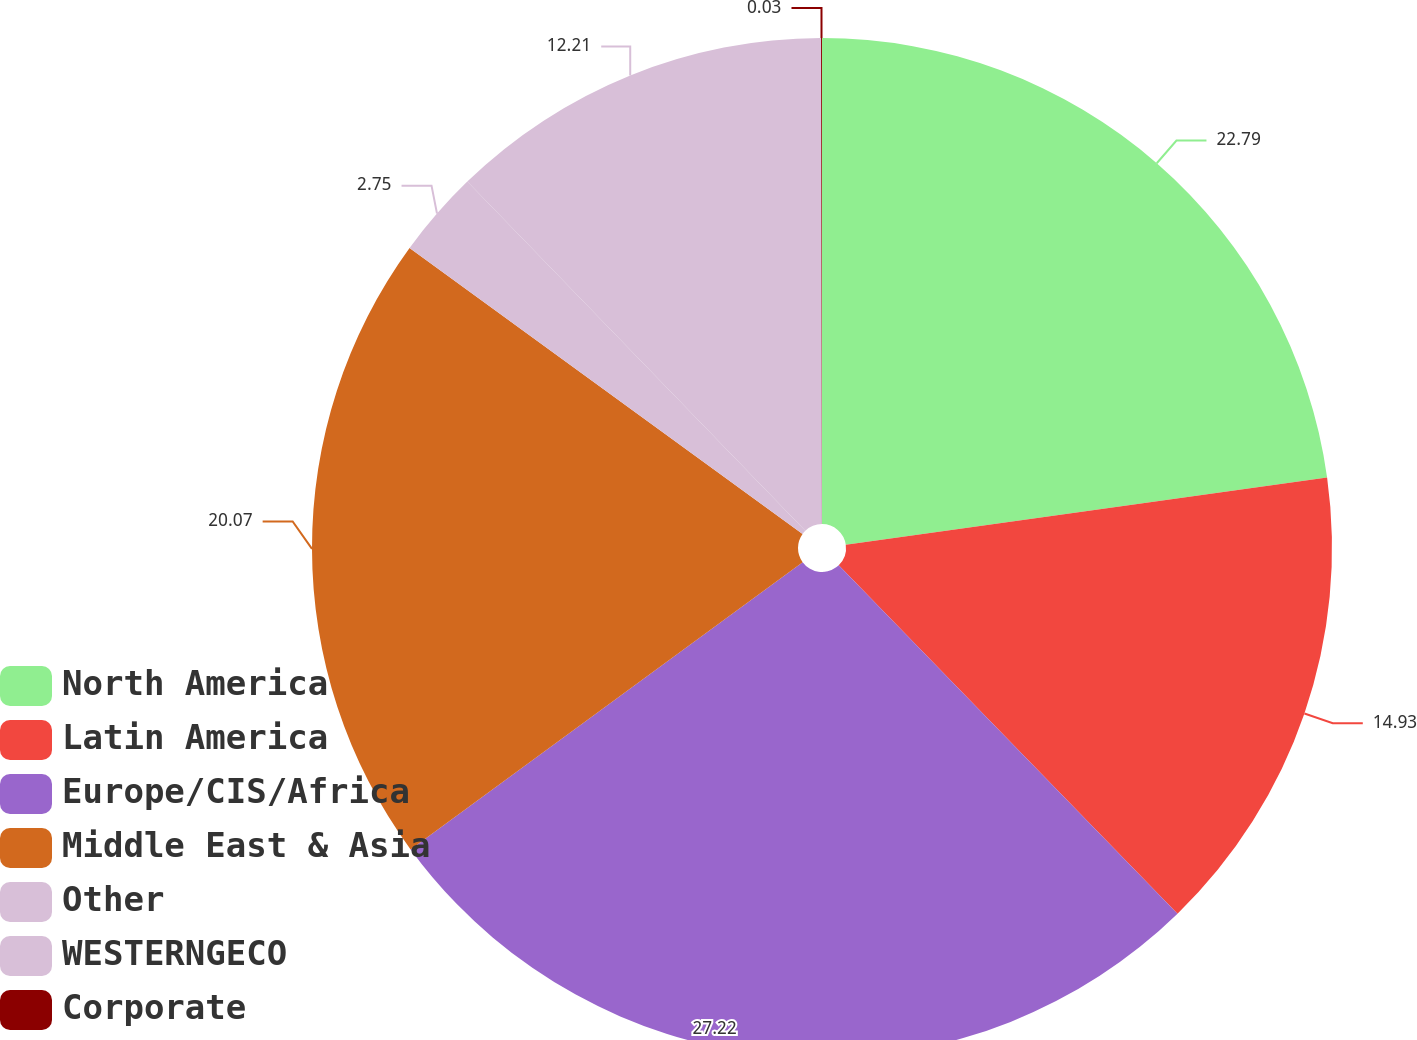Convert chart to OTSL. <chart><loc_0><loc_0><loc_500><loc_500><pie_chart><fcel>North America<fcel>Latin America<fcel>Europe/CIS/Africa<fcel>Middle East & Asia<fcel>Other<fcel>WESTERNGECO<fcel>Corporate<nl><fcel>22.79%<fcel>14.93%<fcel>27.21%<fcel>20.07%<fcel>2.75%<fcel>12.21%<fcel>0.03%<nl></chart> 